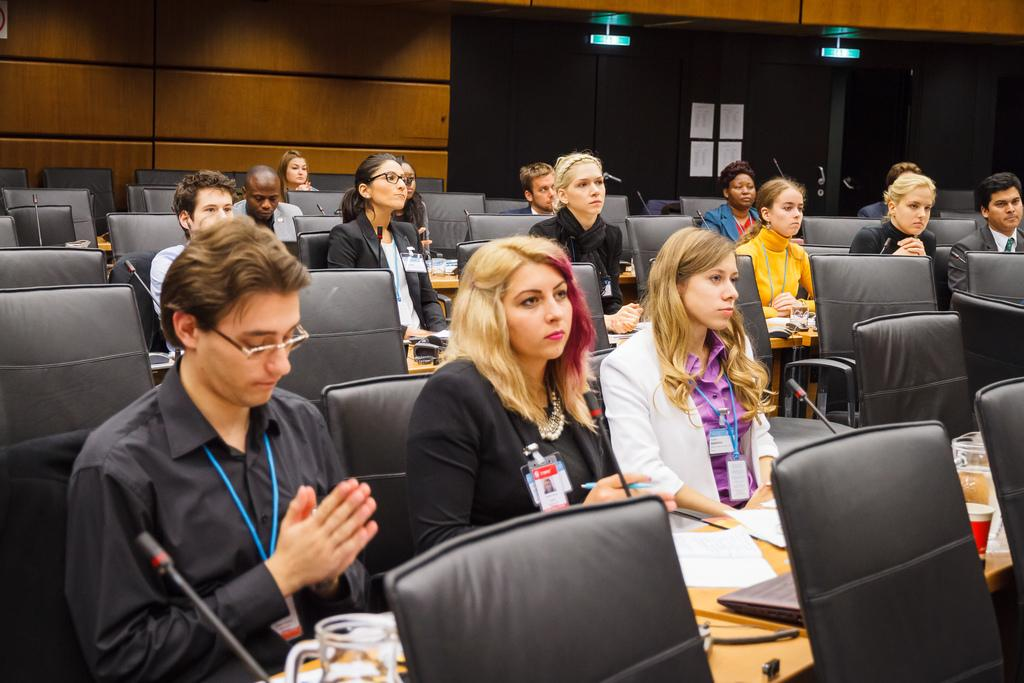What are the people in the image doing? There is a group of people sitting on chairs in the image. What can be seen on the table in the image? There is a laptop, a cup, and a glass with a mic on the table. How much salt is in the crate in the image? There is no crate or salt present in the image. What type of cave can be seen in the background of the image? There is no cave visible in the image; it features a group of people sitting on chairs and objects on a table. 